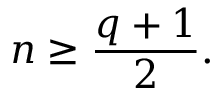<formula> <loc_0><loc_0><loc_500><loc_500>n \geq { \frac { q + 1 } { 2 } } .</formula> 